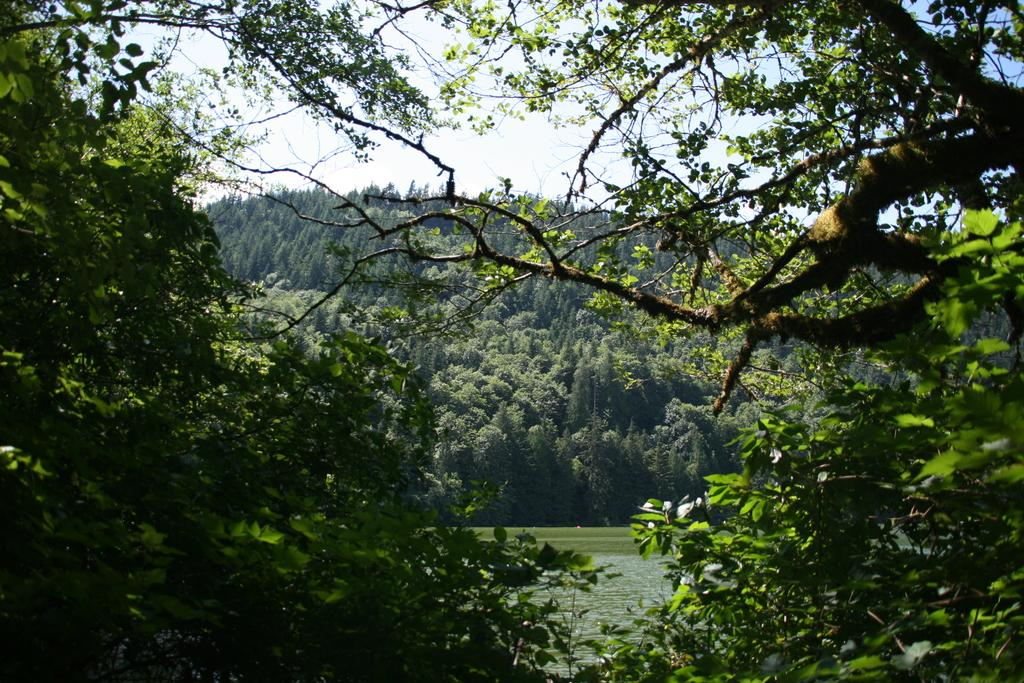What type of vegetation can be seen in the image? There is a group of trees in the image. What natural feature is present in the image besides the trees? There is a water body in the image. What part of the natural environment is visible in the image? The sky is visible in the image. How would you describe the weather based on the appearance of the sky? The sky appears cloudy in the image. What type of car can be seen driving through the field in the image? There is no car or field present in the image; it features a group of trees, a water body, and a cloudy sky. 